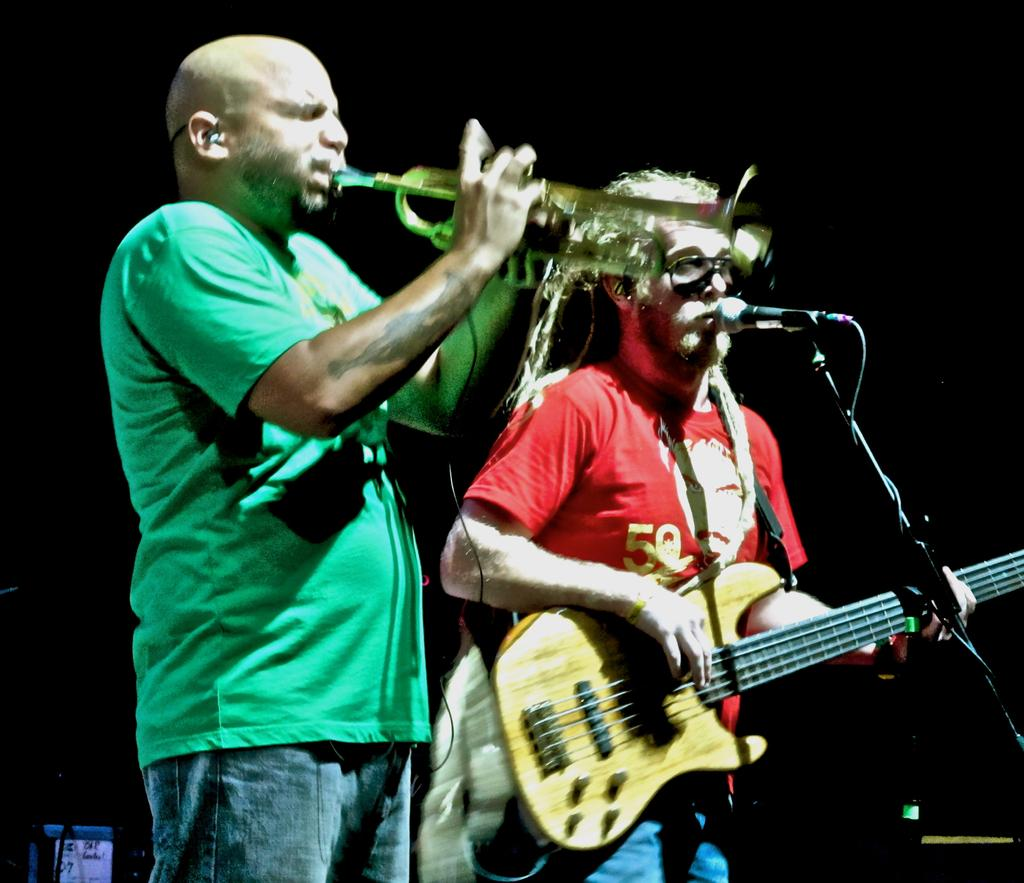How many people are in the image? There are two men in the image. What are the men doing in the image? One man is holding a guitar and playing it, while also singing into a microphone. The other man is playing a trumpet. What can be seen in the background of the image? The background of the image is dark. What type of marble is the snail using to play the trumpet in the image? There is no snail or marble present in the image. Can you tell me how many donkeys are visible in the image? There are no donkeys present in the image. 